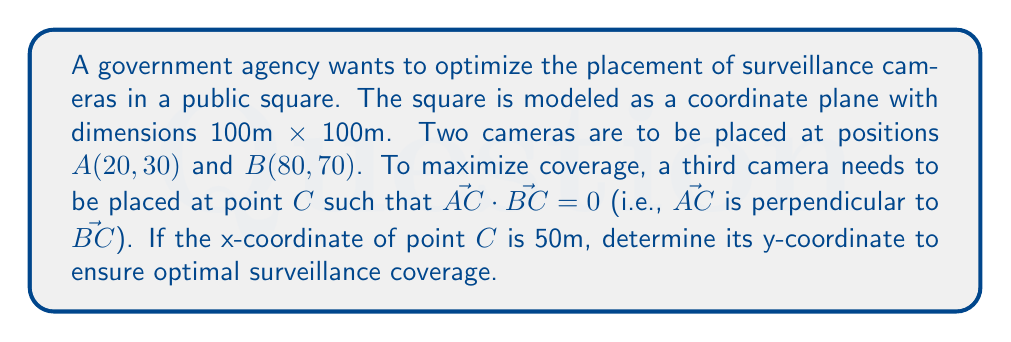What is the answer to this math problem? Let's approach this step-by-step:

1) We are given points $A(20, 30)$ and $B(80, 70)$, and we know the x-coordinate of $C$ is 50.
   Let's represent $C$ as $(50, y)$, where $y$ is unknown.

2) We need to find $\vec{AC}$ and $\vec{BC}$:
   $\vec{AC} = (50-20, y-30) = (30, y-30)$
   $\vec{BC} = (50-80, y-70) = (-30, y-70)$

3) For $\vec{AC}$ to be perpendicular to $\vec{BC}$, their dot product must be zero:

   $\vec{AC} \cdot \vec{BC} = 0$

4) Let's calculate this dot product:
   $(30, y-30) \cdot (-30, y-70) = 0$

5) Expanding this:
   $30(-30) + (y-30)(y-70) = 0$

6) Simplifying:
   $-900 + y^2 - 70y - 30y + 2100 = 0$
   $y^2 - 100y + 1200 = 0$

7) This is a quadratic equation. We can solve it using the quadratic formula:
   $y = \frac{-b \pm \sqrt{b^2 - 4ac}}{2a}$

   Where $a=1$, $b=-100$, and $c=1200$

8) Plugging in these values:
   $y = \frac{100 \pm \sqrt{10000 - 4800}}{2} = \frac{100 \pm \sqrt{5200}}{2}$

9) Simplifying:
   $y = 50 \pm \sqrt{1300}$

10) Since we're dealing with coordinates in a 100m × 100m square, we need the positive solution:
    $y = 50 + \sqrt{1300} \approx 86.05$

Therefore, the optimal y-coordinate for the third camera is approximately 86.05 meters.
Answer: The optimal y-coordinate for the third surveillance camera is approximately 86.05 meters. 